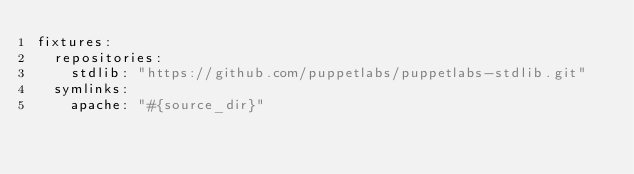<code> <loc_0><loc_0><loc_500><loc_500><_YAML_>fixtures:
  repositories:
    stdlib: "https://github.com/puppetlabs/puppetlabs-stdlib.git"
  symlinks:
    apache: "#{source_dir}"
</code> 